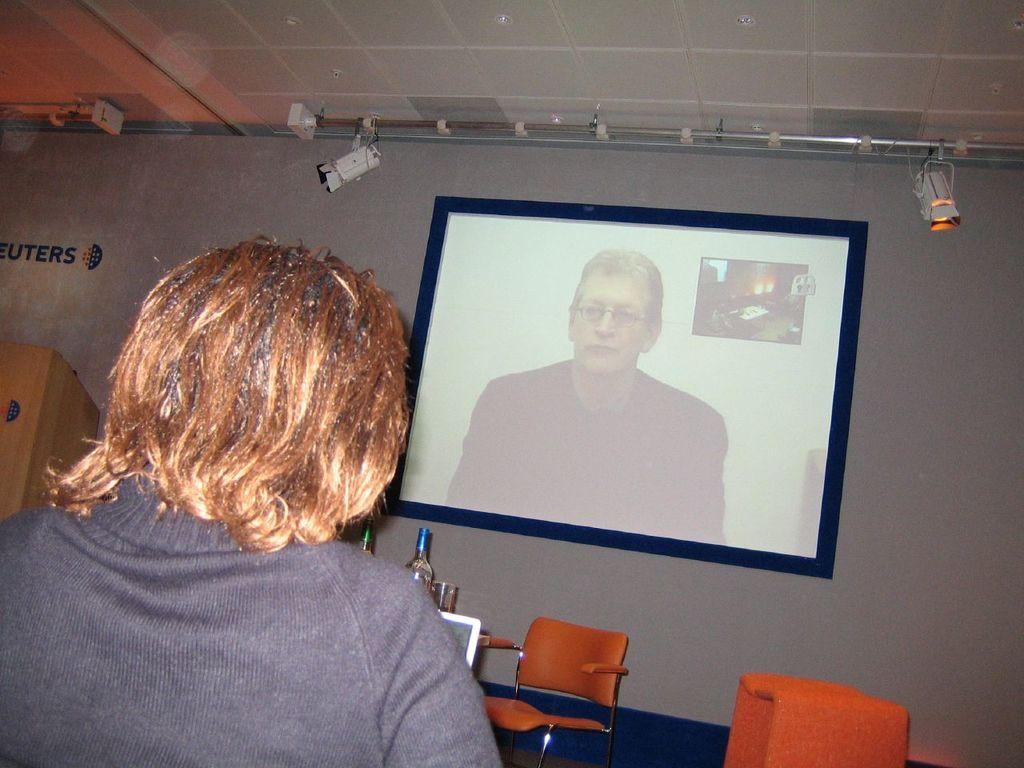What is attached to the wall in the image? There is a screen attached to the wall in the image. Who is present in the image and where are they located? There is a person on the left side of the image looking at the screen. What can be seen in the background of the image? There are two chairs and bottles visible in the background of the image. What type of knot is being used to secure the screen to the wall in the image? There is no knot visible in the image, as the screen appears to be attached to the wall using a different method, such as screws or brackets. 